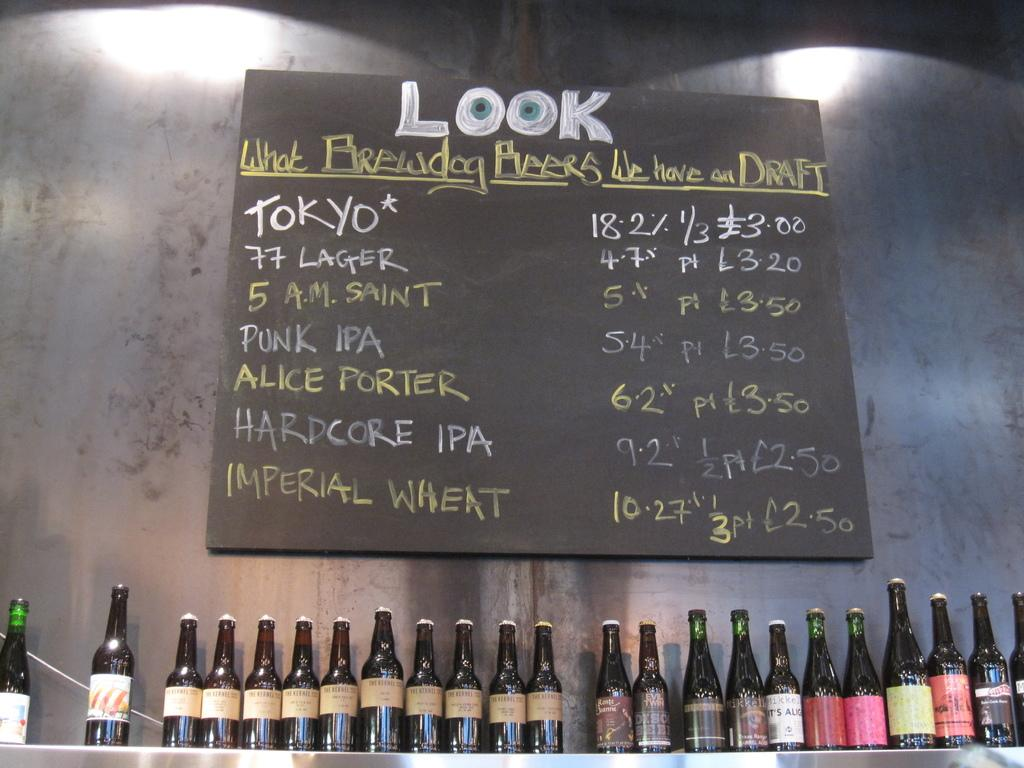Provide a one-sentence caption for the provided image. Beer bottles in a line below a chalk board menu that says "Look What Brewdog Beers We Have on Draft". 